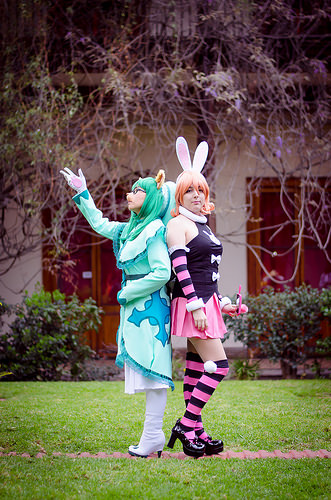<image>
Is there a door behind the girl? Yes. From this viewpoint, the door is positioned behind the girl, with the girl partially or fully occluding the door. 